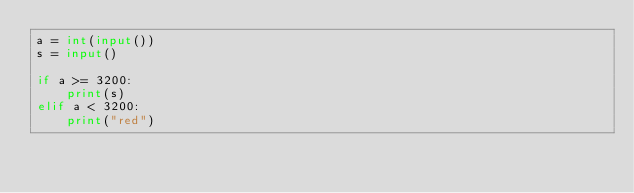<code> <loc_0><loc_0><loc_500><loc_500><_Python_>a = int(input())
s = input()

if a >= 3200:
    print(s)
elif a < 3200:
    print("red")</code> 